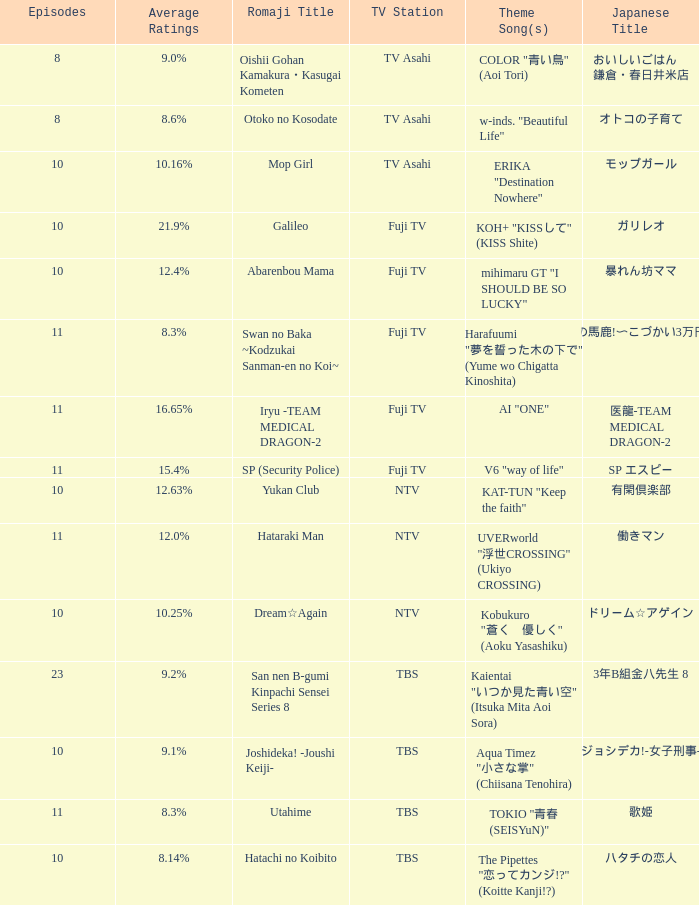What is the Theme Song of the Yukan Club? KAT-TUN "Keep the faith". 